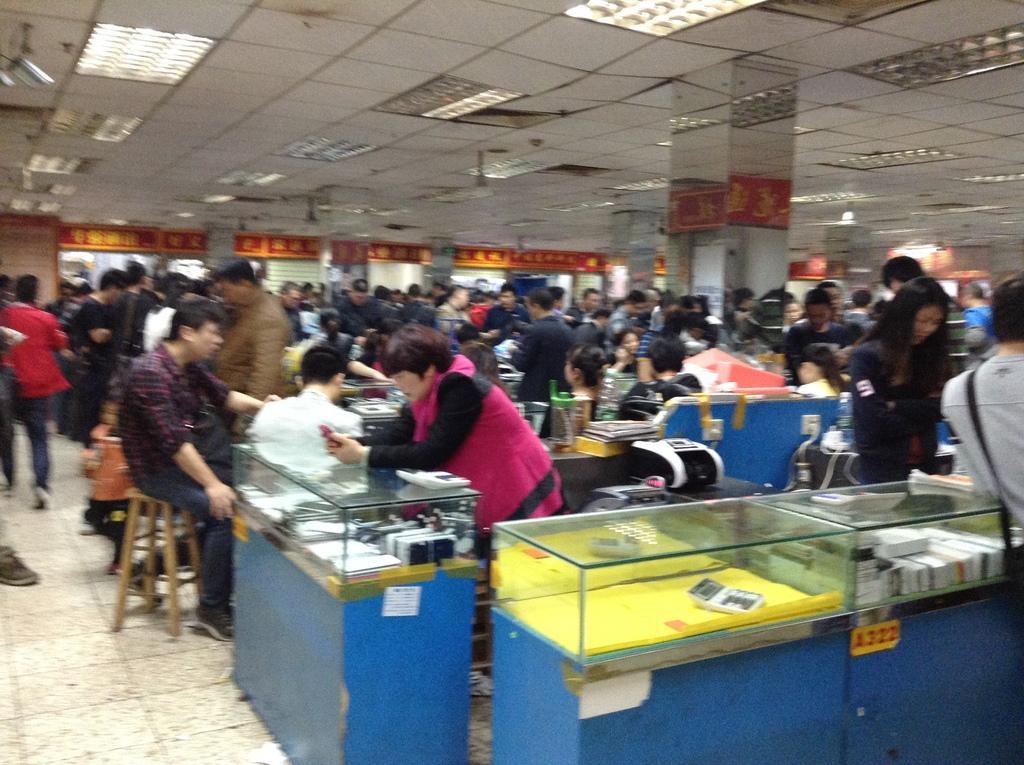Please provide a concise description of this image. In this image we can see counters. There are people. At the top of the image there is ceiling with lights. At the bottom of the image there is floor. 